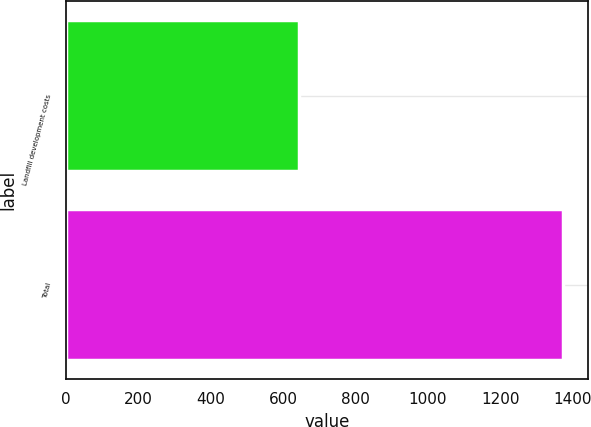Convert chart. <chart><loc_0><loc_0><loc_500><loc_500><bar_chart><fcel>Landfill development costs<fcel>Total<nl><fcel>644.6<fcel>1373.3<nl></chart> 